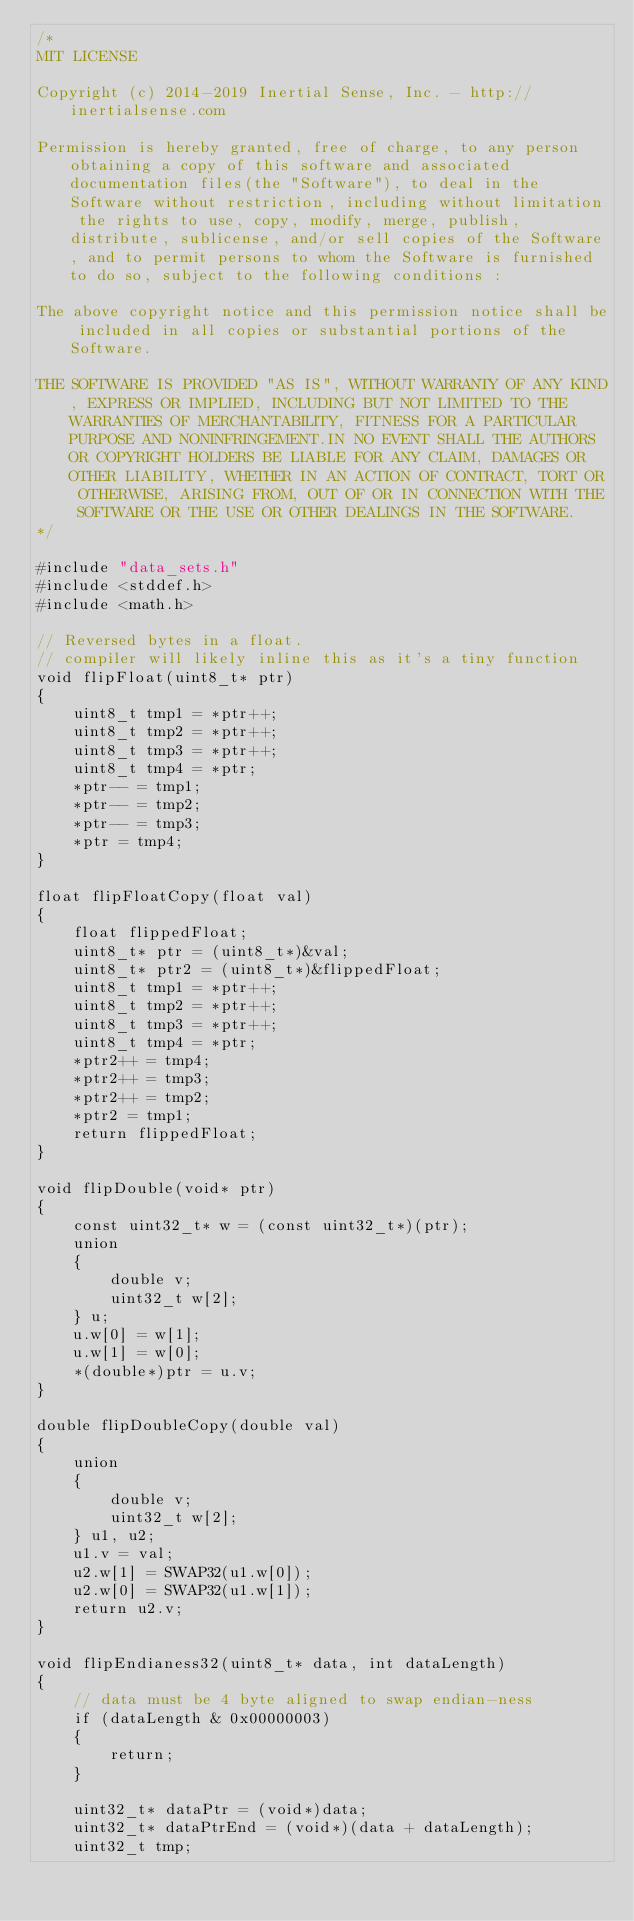<code> <loc_0><loc_0><loc_500><loc_500><_C_>/*
MIT LICENSE

Copyright (c) 2014-2019 Inertial Sense, Inc. - http://inertialsense.com

Permission is hereby granted, free of charge, to any person obtaining a copy of this software and associated documentation files(the "Software"), to deal in the Software without restriction, including without limitation the rights to use, copy, modify, merge, publish, distribute, sublicense, and/or sell copies of the Software, and to permit persons to whom the Software is furnished to do so, subject to the following conditions :

The above copyright notice and this permission notice shall be included in all copies or substantial portions of the Software.

THE SOFTWARE IS PROVIDED "AS IS", WITHOUT WARRANTY OF ANY KIND, EXPRESS OR IMPLIED, INCLUDING BUT NOT LIMITED TO THE WARRANTIES OF MERCHANTABILITY, FITNESS FOR A PARTICULAR PURPOSE AND NONINFRINGEMENT.IN NO EVENT SHALL THE AUTHORS OR COPYRIGHT HOLDERS BE LIABLE FOR ANY CLAIM, DAMAGES OR OTHER LIABILITY, WHETHER IN AN ACTION OF CONTRACT, TORT OR OTHERWISE, ARISING FROM, OUT OF OR IN CONNECTION WITH THE SOFTWARE OR THE USE OR OTHER DEALINGS IN THE SOFTWARE.
*/

#include "data_sets.h"
#include <stddef.h>
#include <math.h>

// Reversed bytes in a float.
// compiler will likely inline this as it's a tiny function
void flipFloat(uint8_t* ptr)
{
	uint8_t tmp1 = *ptr++;
	uint8_t tmp2 = *ptr++;
	uint8_t tmp3 = *ptr++;
	uint8_t tmp4 = *ptr;
	*ptr-- = tmp1;
	*ptr-- = tmp2;
	*ptr-- = tmp3;
	*ptr = tmp4;
}

float flipFloatCopy(float val)
{
	float flippedFloat;
	uint8_t* ptr = (uint8_t*)&val;
	uint8_t* ptr2 = (uint8_t*)&flippedFloat;
	uint8_t tmp1 = *ptr++;
	uint8_t tmp2 = *ptr++;
	uint8_t tmp3 = *ptr++;
	uint8_t tmp4 = *ptr;
	*ptr2++ = tmp4;
	*ptr2++ = tmp3;
	*ptr2++ = tmp2;
	*ptr2 = tmp1;
	return flippedFloat;
}

void flipDouble(void* ptr)
{
	const uint32_t* w = (const uint32_t*)(ptr);
	union
	{
		double v;
		uint32_t w[2];
	} u;
	u.w[0] = w[1];
	u.w[1] = w[0];
	*(double*)ptr = u.v;
}

double flipDoubleCopy(double val)
{
	union
	{
		double v;
		uint32_t w[2];
	} u1, u2;
	u1.v = val;
	u2.w[1] = SWAP32(u1.w[0]);
	u2.w[0] = SWAP32(u1.w[1]);
	return u2.v;
}

void flipEndianess32(uint8_t* data, int dataLength)
{
	// data must be 4 byte aligned to swap endian-ness
	if (dataLength & 0x00000003)
	{
		return;
	}
	
	uint32_t* dataPtr = (void*)data;
	uint32_t* dataPtrEnd = (void*)(data + dataLength);
	uint32_t tmp;</code> 